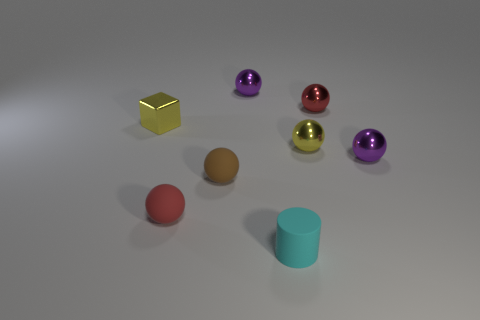Subtract all tiny red matte balls. How many balls are left? 5 Add 1 large brown rubber balls. How many objects exist? 9 Subtract all red spheres. How many spheres are left? 4 Subtract 2 spheres. How many spheres are left? 4 Subtract all balls. How many objects are left? 2 Add 1 small cyan rubber cylinders. How many small cyan rubber cylinders are left? 2 Add 7 metallic cylinders. How many metallic cylinders exist? 7 Subtract 0 purple cubes. How many objects are left? 8 Subtract all gray cylinders. Subtract all brown blocks. How many cylinders are left? 1 Subtract all red cubes. How many purple balls are left? 2 